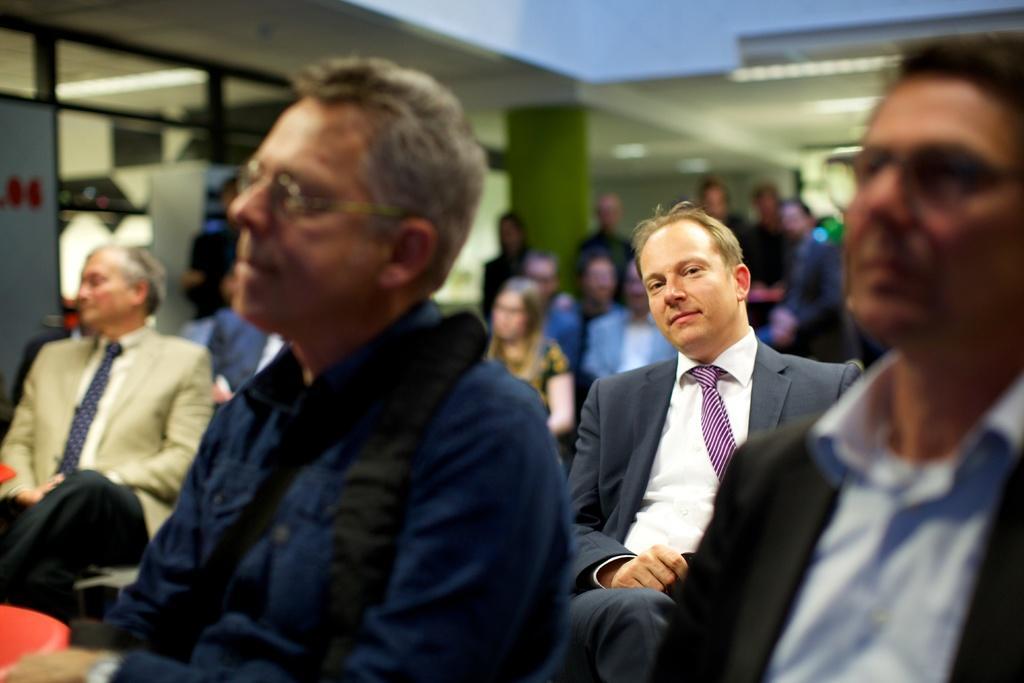Could you give a brief overview of what you see in this image? In this image, I can see a group of people sitting and a group of people standing. In the background, I can see the glass windows and a pillar. 